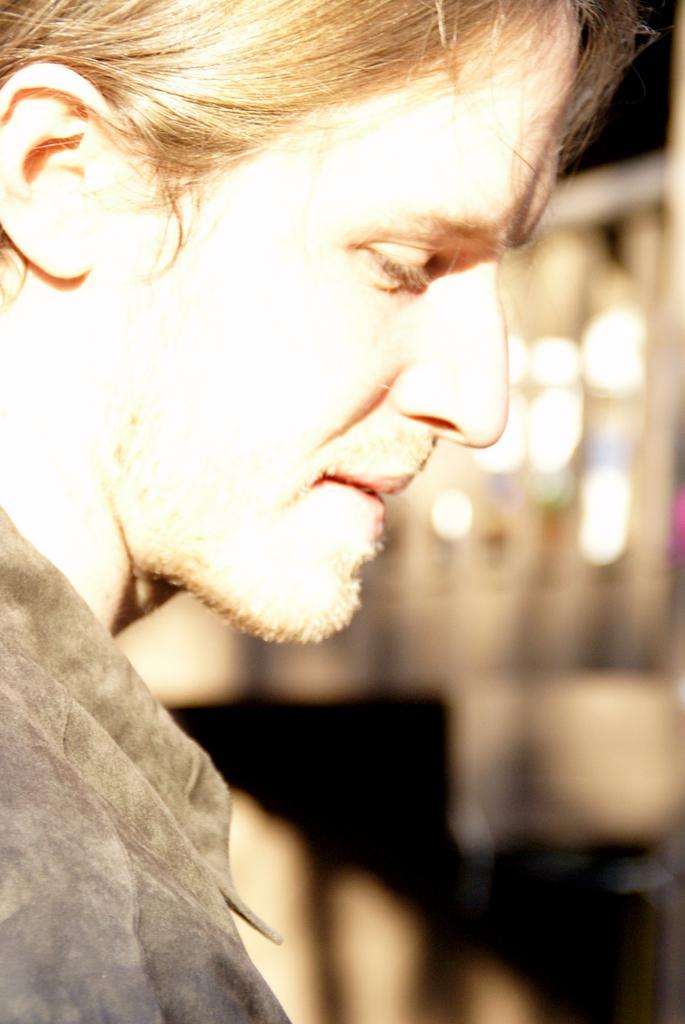Could you give a brief overview of what you see in this image? In this image I can see a person with blonde hair is wearing dress. In the background I can see few other objects which are blurry. 